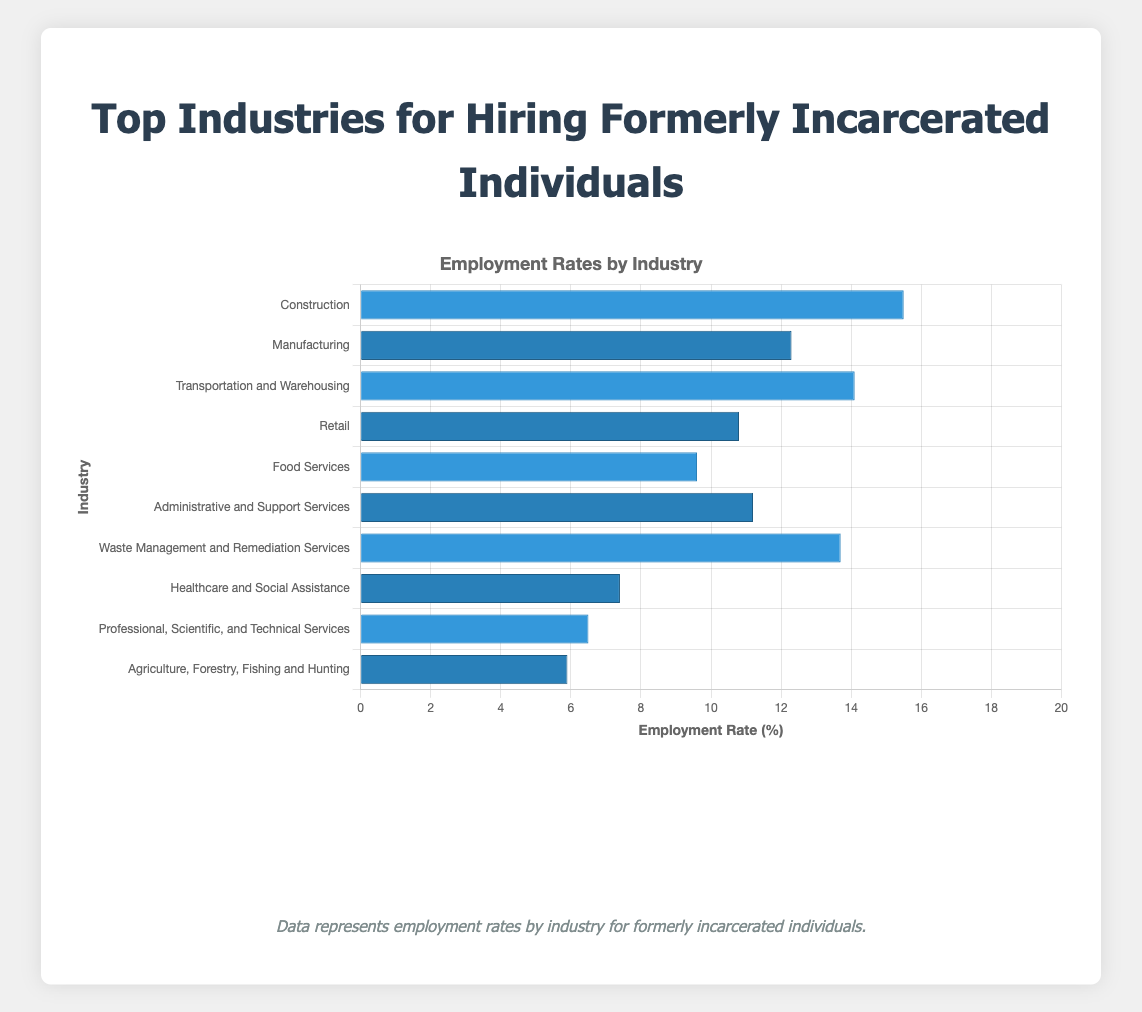what industry has the highest employment rate for formerly incarcerated individuals? The highest employment rate can be identified by locating the tallest bar. The tallest bar represents "Construction" with an employment rate of 15.5%.
Answer: Construction What is the difference in employment rate between the "Construction" and "Healthcare and Social Assistance" industries? The employment rates are 15.5% for "Construction" and 7.4% for "Healthcare and Social Assistance". The difference is calculated as 15.5% - 7.4% = 8.1%.
Answer: 8.1% Is the employment rate for "Retail" higher or lower than the employment rate for "Food Services"? To determine this, compare the heights of the bars for "Retail" (10.8%) and "Food Services" (9.6%). Since 10.8% is greater than 9.6%, "Retail" has a higher employment rate.
Answer: Higher What is the average employment rate for the industries shown? Sum the employment rates of all industries: 15.5 + 12.3 + 14.1 + 10.8 + 9.6 + 11.2 + 13.7 + 7.4 + 6.5 + 5.9 = 96.9. Divide by the number of industries (10): 96.9 / 10 = 9.69%.
Answer: 9.69% Which industry has the lowest employment rate for formerly incarcerated individuals? The shortest bar on the chart represents the lowest employment rate. "Agriculture, Forestry, Fishing and Hunting" has the shortest bar with an employment rate of 5.9%.
Answer: Agriculture, Forestry, Fishing and Hunting How much more employment does "Transportation and Warehousing" provide compared to "Professional, Scientific, and Technical Services"? The employment rates are 14.1% for "Transportation and Warehousing" and 6.5% for "Professional, Scientific, and Technical Services". The difference is 14.1% - 6.5% = 7.6%.
Answer: 7.6% What is the combined employment rate for "Administrative and Support Services" and "Waste Management and Remediation Services"? Add the employment rates: 11.2% (Administrative and Support Services) + 13.7% (Waste Management and Remediation Services) = 24.9%.
Answer: 24.9% Which industries have an employment rate above 10%? Identify the bars taller than the 10% mark: "Construction" (15.5%), "Manufacturing" (12.3%), "Transportation and Warehousing" (14.1%), "Retail" (10.8%), "Administrative and Support Services" (11.2%), and "Waste Management and Remediation Services" (13.7%).
Answer: Construction, Manufacturing, Transportation and Warehousing, Retail, Administrative and Support Services, Waste Management and Remediation Services 